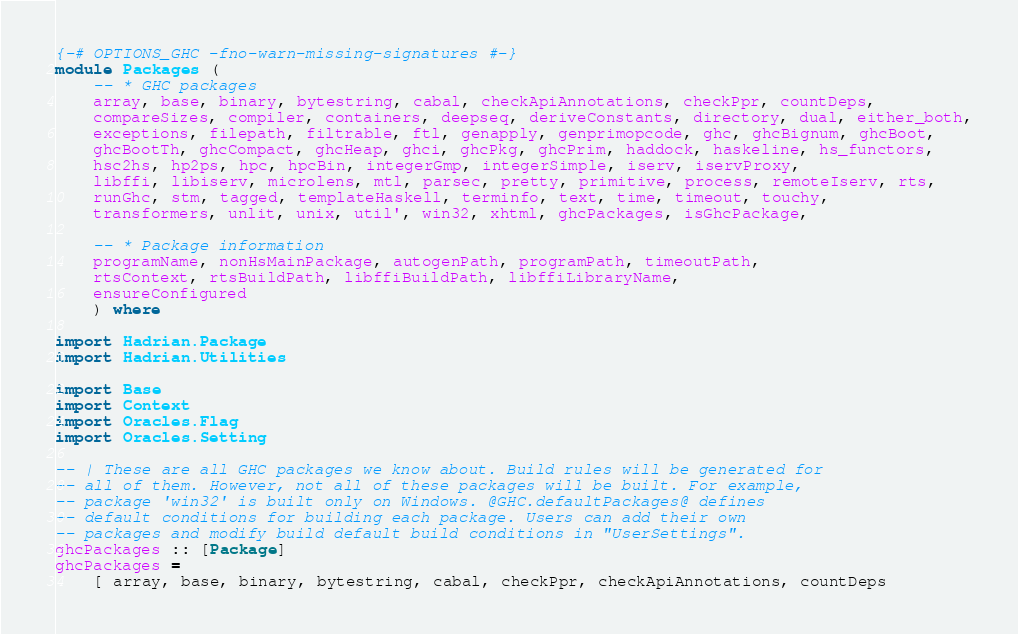Convert code to text. <code><loc_0><loc_0><loc_500><loc_500><_Haskell_>{-# OPTIONS_GHC -fno-warn-missing-signatures #-}
module Packages (
    -- * GHC packages
    array, base, binary, bytestring, cabal, checkApiAnnotations, checkPpr, countDeps,
    compareSizes, compiler, containers, deepseq, deriveConstants, directory, dual, either_both,
    exceptions, filepath, filtrable, ftl, genapply, genprimopcode, ghc, ghcBignum, ghcBoot,
    ghcBootTh, ghcCompact, ghcHeap, ghci, ghcPkg, ghcPrim, haddock, haskeline, hs_functors,
    hsc2hs, hp2ps, hpc, hpcBin, integerGmp, integerSimple, iserv, iservProxy,
    libffi, libiserv, microlens, mtl, parsec, pretty, primitive, process, remoteIserv, rts,
    runGhc, stm, tagged, templateHaskell, terminfo, text, time, timeout, touchy,
    transformers, unlit, unix, util', win32, xhtml, ghcPackages, isGhcPackage,

    -- * Package information
    programName, nonHsMainPackage, autogenPath, programPath, timeoutPath,
    rtsContext, rtsBuildPath, libffiBuildPath, libffiLibraryName,
    ensureConfigured
    ) where

import Hadrian.Package
import Hadrian.Utilities

import Base
import Context
import Oracles.Flag
import Oracles.Setting

-- | These are all GHC packages we know about. Build rules will be generated for
-- all of them. However, not all of these packages will be built. For example,
-- package 'win32' is built only on Windows. @GHC.defaultPackages@ defines
-- default conditions for building each package. Users can add their own
-- packages and modify build default build conditions in "UserSettings".
ghcPackages :: [Package]
ghcPackages =
    [ array, base, binary, bytestring, cabal, checkPpr, checkApiAnnotations, countDeps</code> 